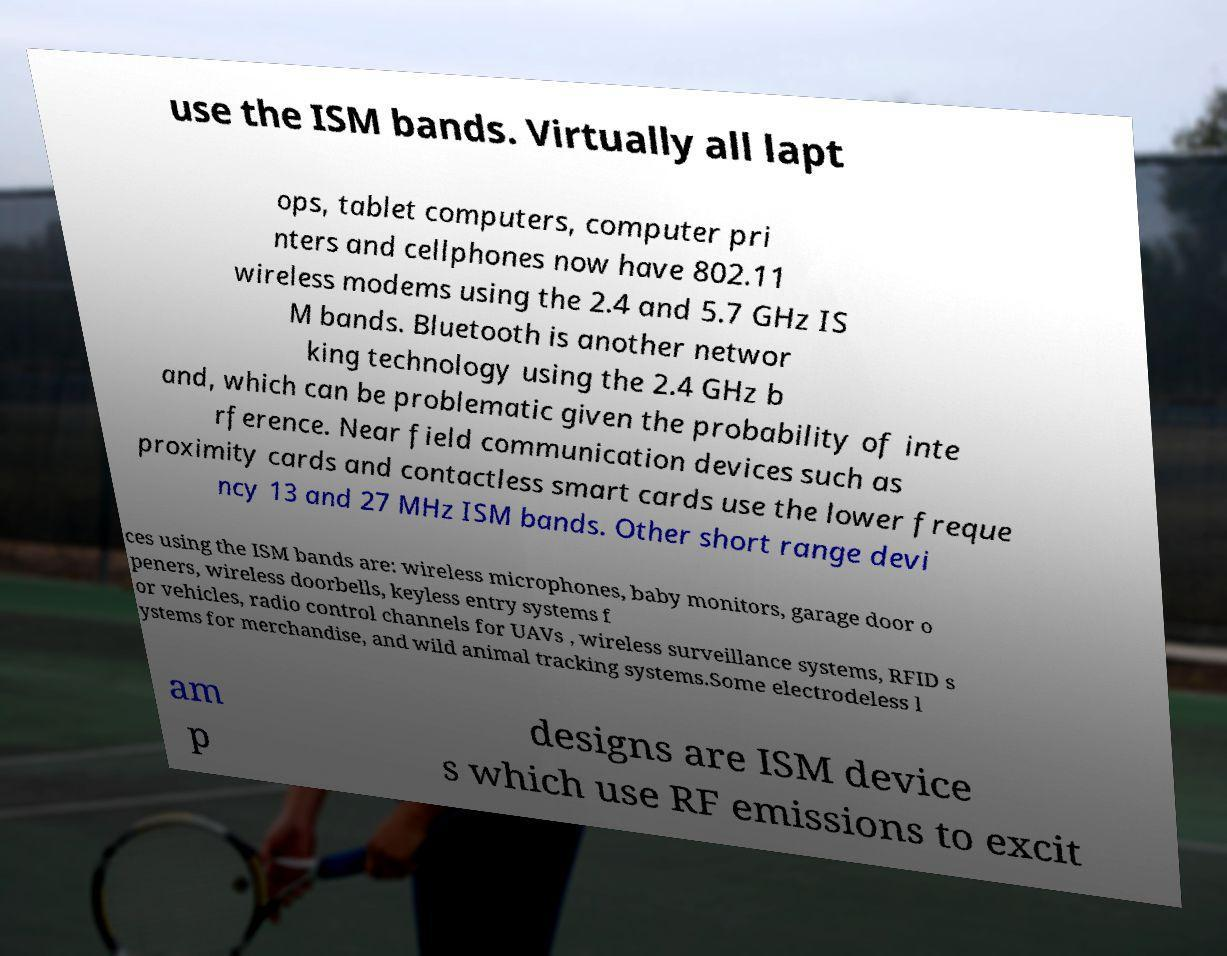Please identify and transcribe the text found in this image. use the ISM bands. Virtually all lapt ops, tablet computers, computer pri nters and cellphones now have 802.11 wireless modems using the 2.4 and 5.7 GHz IS M bands. Bluetooth is another networ king technology using the 2.4 GHz b and, which can be problematic given the probability of inte rference. Near field communication devices such as proximity cards and contactless smart cards use the lower freque ncy 13 and 27 MHz ISM bands. Other short range devi ces using the ISM bands are: wireless microphones, baby monitors, garage door o peners, wireless doorbells, keyless entry systems f or vehicles, radio control channels for UAVs , wireless surveillance systems, RFID s ystems for merchandise, and wild animal tracking systems.Some electrodeless l am p designs are ISM device s which use RF emissions to excit 